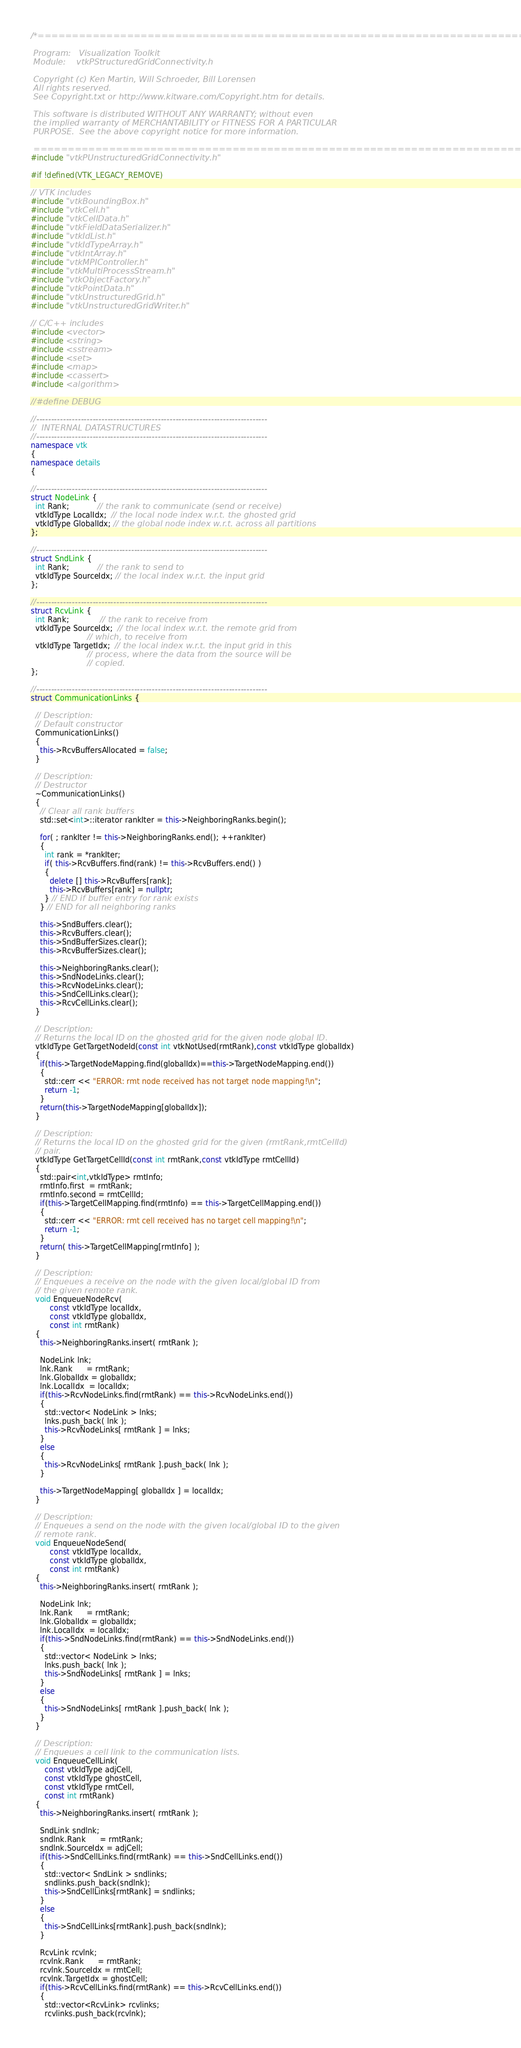Convert code to text. <code><loc_0><loc_0><loc_500><loc_500><_C++_>/*=========================================================================

 Program:   Visualization Toolkit
 Module:    vtkPStructuredGridConnectivity.h

 Copyright (c) Ken Martin, Will Schroeder, Bill Lorensen
 All rights reserved.
 See Copyright.txt or http://www.kitware.com/Copyright.htm for details.

 This software is distributed WITHOUT ANY WARRANTY; without even
 the implied warranty of MERCHANTABILITY or FITNESS FOR A PARTICULAR
 PURPOSE.  See the above copyright notice for more information.

 =========================================================================*/
#include "vtkPUnstructuredGridConnectivity.h"

#if !defined(VTK_LEGACY_REMOVE)

// VTK includes
#include "vtkBoundingBox.h"
#include "vtkCell.h"
#include "vtkCellData.h"
#include "vtkFieldDataSerializer.h"
#include "vtkIdList.h"
#include "vtkIdTypeArray.h"
#include "vtkIntArray.h"
#include "vtkMPIController.h"
#include "vtkMultiProcessStream.h"
#include "vtkObjectFactory.h"
#include "vtkPointData.h"
#include "vtkUnstructuredGrid.h"
#include "vtkUnstructuredGridWriter.h"

// C/C++ includes
#include <vector>
#include <string>
#include <sstream>
#include <set>
#include <map>
#include <cassert>
#include <algorithm>

//#define DEBUG

//------------------------------------------------------------------------------
//  INTERNAL DATASTRUCTURES
//------------------------------------------------------------------------------
namespace vtk
{
namespace details
{

//------------------------------------------------------------------------------
struct NodeLink {
  int Rank;            // the rank to communicate (send or receive)
  vtkIdType LocalIdx;  // the local node index w.r.t. the ghosted grid
  vtkIdType GlobalIdx; // the global node index w.r.t. across all partitions
};

//------------------------------------------------------------------------------
struct SndLink {
  int Rank;            // the rank to send to
  vtkIdType SourceIdx; // the local index w.r.t. the input grid
};

//------------------------------------------------------------------------------
struct RcvLink {
  int Rank;             // the rank to receive from
  vtkIdType SourceIdx;  // the local index w.r.t. the remote grid from
                        // which, to receive from
  vtkIdType TargetIdx;  // the local index w.r.t. the input grid in this
                        // process, where the data from the source will be
                        // copied.
};

//------------------------------------------------------------------------------
struct CommunicationLinks {

  // Description:
  // Default constructor
  CommunicationLinks()
  {
    this->RcvBuffersAllocated = false;
  }

  // Description:
  // Destructor
  ~CommunicationLinks()
  {
    // Clear all rank buffers
    std::set<int>::iterator rankIter = this->NeighboringRanks.begin();

    for( ; rankIter != this->NeighboringRanks.end(); ++rankIter)
    {
      int rank = *rankIter;
      if( this->RcvBuffers.find(rank) != this->RcvBuffers.end() )
      {
        delete [] this->RcvBuffers[rank];
        this->RcvBuffers[rank] = nullptr;
      } // END if buffer entry for rank exists
    } // END for all neighboring ranks

    this->SndBuffers.clear();
    this->RcvBuffers.clear();
    this->SndBufferSizes.clear();
    this->RcvBufferSizes.clear();

    this->NeighboringRanks.clear();
    this->SndNodeLinks.clear();
    this->RcvNodeLinks.clear();
    this->SndCellLinks.clear();
    this->RcvCellLinks.clear();
  }

  // Description:
  // Returns the local ID on the ghosted grid for the given node global ID.
  vtkIdType GetTargetNodeId(const int vtkNotUsed(rmtRank),const vtkIdType globalIdx)
  {
    if(this->TargetNodeMapping.find(globalIdx)==this->TargetNodeMapping.end())
    {
      std::cerr << "ERROR: rmt node received has not target node mapping!\n";
      return -1;
    }
    return(this->TargetNodeMapping[globalIdx]);
  }

  // Description:
  // Returns the local ID on the ghosted grid for the given (rmtRank,rmtCellId)
  // pair.
  vtkIdType GetTargetCellId(const int rmtRank,const vtkIdType rmtCellId)
  {
    std::pair<int,vtkIdType> rmtInfo;
    rmtInfo.first  = rmtRank;
    rmtInfo.second = rmtCellId;
    if(this->TargetCellMapping.find(rmtInfo) == this->TargetCellMapping.end())
    {
      std::cerr << "ERROR: rmt cell received has no target cell mapping!\n";
      return -1;
    }
    return( this->TargetCellMapping[rmtInfo] );
  }

  // Description:
  // Enqueues a receive on the node with the given local/global ID from
  // the given remote rank.
  void EnqueueNodeRcv(
        const vtkIdType localIdx,
        const vtkIdType globalIdx,
        const int rmtRank)
  {
    this->NeighboringRanks.insert( rmtRank );

    NodeLink lnk;
    lnk.Rank      = rmtRank;
    lnk.GlobalIdx = globalIdx;
    lnk.LocalIdx  = localIdx;
    if(this->RcvNodeLinks.find(rmtRank) == this->RcvNodeLinks.end())
    {
      std::vector< NodeLink > lnks;
      lnks.push_back( lnk );
      this->RcvNodeLinks[ rmtRank ] = lnks;
    }
    else
    {
      this->RcvNodeLinks[ rmtRank ].push_back( lnk );
    }

    this->TargetNodeMapping[ globalIdx ] = localIdx;
  }

  // Description:
  // Enqueues a send on the node with the given local/global ID to the given
  // remote rank.
  void EnqueueNodeSend(
        const vtkIdType localIdx,
        const vtkIdType globalIdx,
        const int rmtRank)
  {
    this->NeighboringRanks.insert( rmtRank );

    NodeLink lnk;
    lnk.Rank      = rmtRank;
    lnk.GlobalIdx = globalIdx;
    lnk.LocalIdx  = localIdx;
    if(this->SndNodeLinks.find(rmtRank) == this->SndNodeLinks.end())
    {
      std::vector< NodeLink > lnks;
      lnks.push_back( lnk );
      this->SndNodeLinks[ rmtRank ] = lnks;
    }
    else
    {
      this->SndNodeLinks[ rmtRank ].push_back( lnk );
    }
  }

  // Description:
  // Enqueues a cell link to the communication lists.
  void EnqueueCellLink(
      const vtkIdType adjCell,
      const vtkIdType ghostCell,
      const vtkIdType rmtCell,
      const int rmtRank)
  {
    this->NeighboringRanks.insert( rmtRank );

    SndLink sndlnk;
    sndlnk.Rank      = rmtRank;
    sndlnk.SourceIdx = adjCell;
    if(this->SndCellLinks.find(rmtRank) == this->SndCellLinks.end())
    {
      std::vector< SndLink > sndlinks;
      sndlinks.push_back(sndlnk);
      this->SndCellLinks[rmtRank] = sndlinks;
    }
    else
    {
      this->SndCellLinks[rmtRank].push_back(sndlnk);
    }

    RcvLink rcvlnk;
    rcvlnk.Rank      = rmtRank;
    rcvlnk.SourceIdx = rmtCell;
    rcvlnk.TargetIdx = ghostCell;
    if(this->RcvCellLinks.find(rmtRank) == this->RcvCellLinks.end())
    {
      std::vector<RcvLink> rcvlinks;
      rcvlinks.push_back(rcvlnk);</code> 